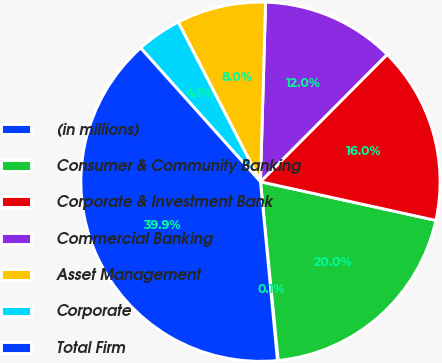Convert chart. <chart><loc_0><loc_0><loc_500><loc_500><pie_chart><fcel>(in millions)<fcel>Consumer & Community Banking<fcel>Corporate & Investment Bank<fcel>Commercial Banking<fcel>Asset Management<fcel>Corporate<fcel>Total Firm<nl><fcel>0.07%<fcel>19.97%<fcel>15.99%<fcel>12.01%<fcel>8.03%<fcel>4.05%<fcel>39.88%<nl></chart> 